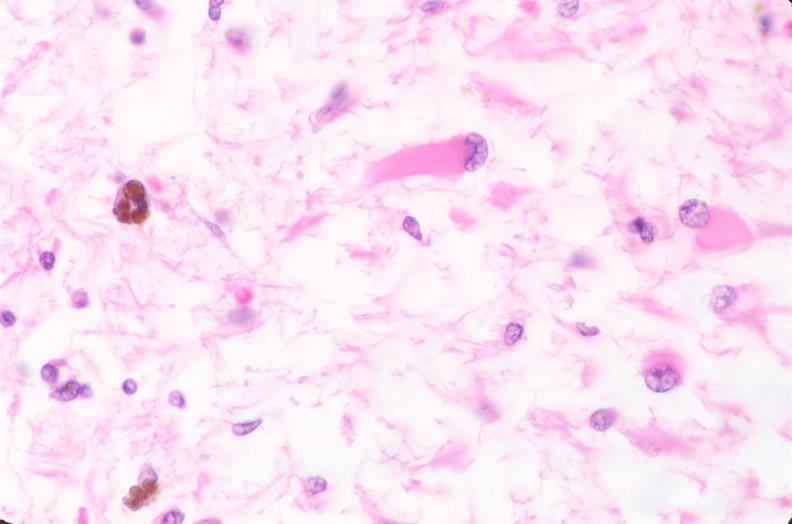does this image show brain, infarct due to ruptured saccular aneurysm and thrombosis of right middle cerebral artery, plamacytic astrocytes?
Answer the question using a single word or phrase. Yes 